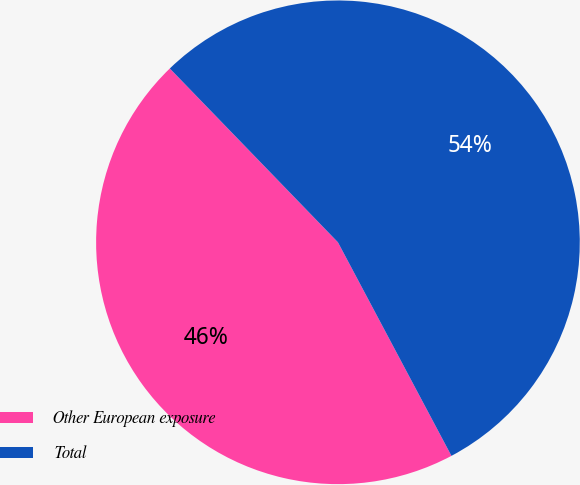<chart> <loc_0><loc_0><loc_500><loc_500><pie_chart><fcel>Other European exposure<fcel>Total<nl><fcel>45.54%<fcel>54.46%<nl></chart> 